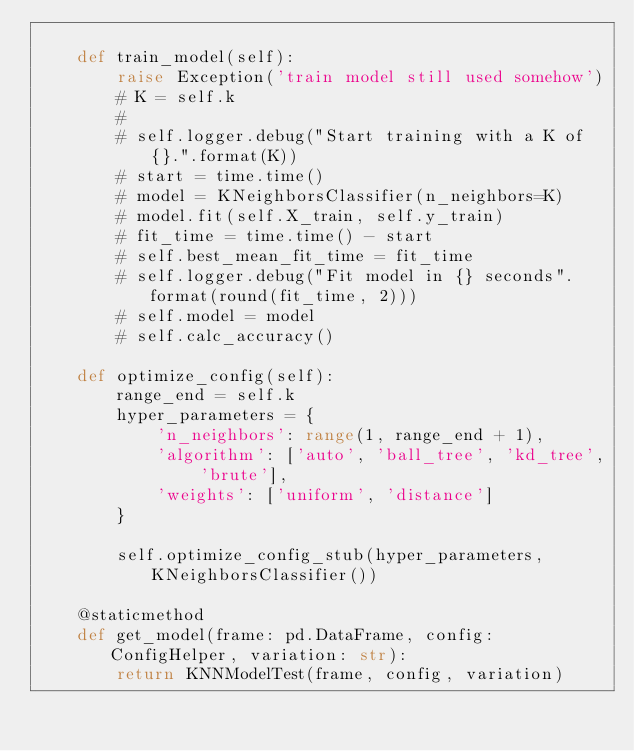<code> <loc_0><loc_0><loc_500><loc_500><_Python_>
    def train_model(self):
        raise Exception('train model still used somehow')
        # K = self.k
        #
        # self.logger.debug("Start training with a K of {}.".format(K))
        # start = time.time()
        # model = KNeighborsClassifier(n_neighbors=K)
        # model.fit(self.X_train, self.y_train)
        # fit_time = time.time() - start
        # self.best_mean_fit_time = fit_time
        # self.logger.debug("Fit model in {} seconds".format(round(fit_time, 2)))
        # self.model = model
        # self.calc_accuracy()

    def optimize_config(self):
        range_end = self.k
        hyper_parameters = {
            'n_neighbors': range(1, range_end + 1),
            'algorithm': ['auto', 'ball_tree', 'kd_tree', 'brute'],
            'weights': ['uniform', 'distance']
        }

        self.optimize_config_stub(hyper_parameters, KNeighborsClassifier())

    @staticmethod
    def get_model(frame: pd.DataFrame, config: ConfigHelper, variation: str):
        return KNNModelTest(frame, config, variation)
</code> 